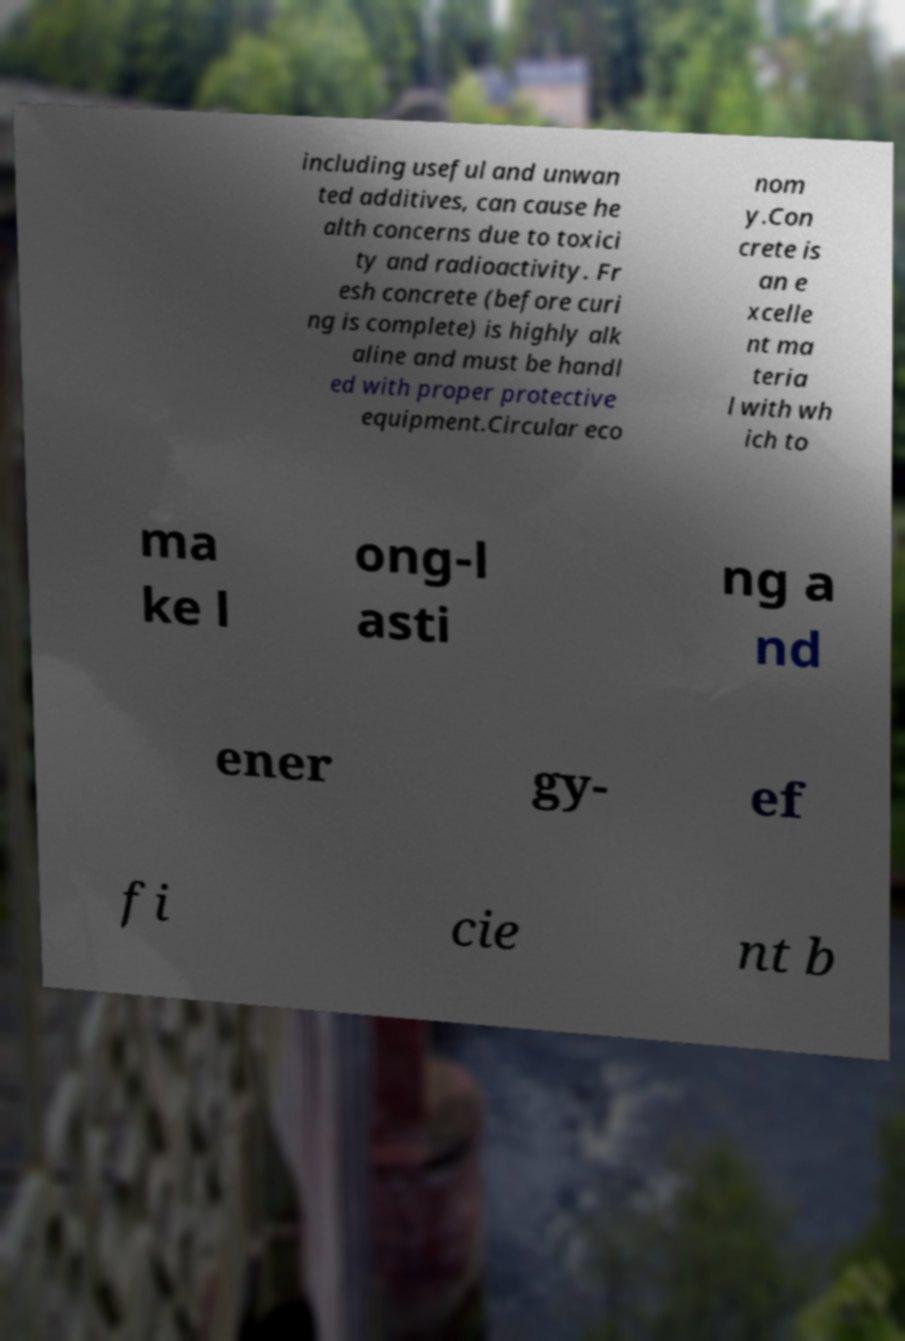Please read and relay the text visible in this image. What does it say? including useful and unwan ted additives, can cause he alth concerns due to toxici ty and radioactivity. Fr esh concrete (before curi ng is complete) is highly alk aline and must be handl ed with proper protective equipment.Circular eco nom y.Con crete is an e xcelle nt ma teria l with wh ich to ma ke l ong-l asti ng a nd ener gy- ef fi cie nt b 